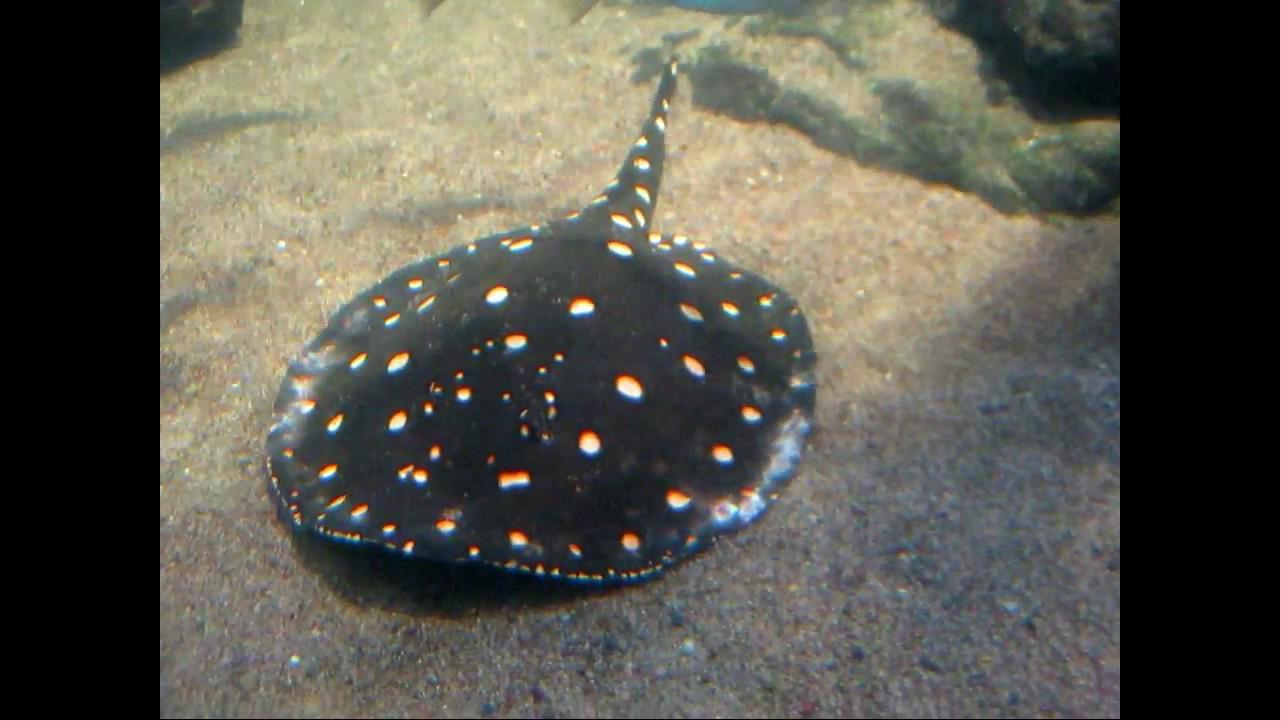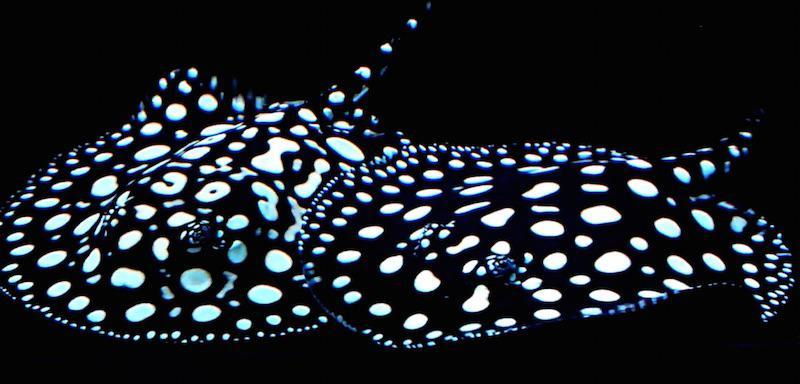The first image is the image on the left, the second image is the image on the right. Analyze the images presented: Is the assertion "There are two stingrays." valid? Answer yes or no. No. The first image is the image on the left, the second image is the image on the right. For the images displayed, is the sentence "There are at least 2 black stingrays with white spots." factually correct? Answer yes or no. Yes. 